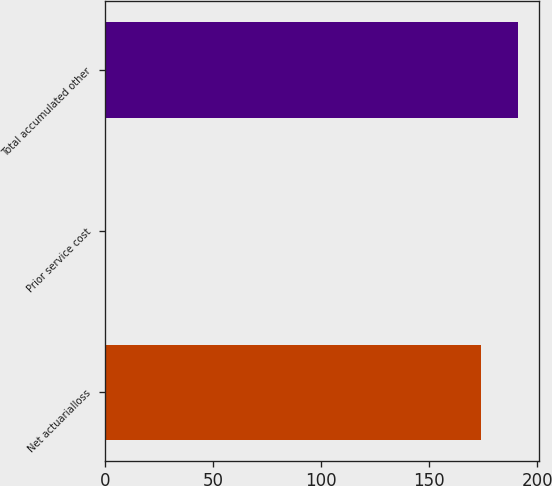Convert chart to OTSL. <chart><loc_0><loc_0><loc_500><loc_500><bar_chart><fcel>Net actuarialloss<fcel>Prior service cost<fcel>Total accumulated other<nl><fcel>173.9<fcel>0.4<fcel>191.29<nl></chart> 